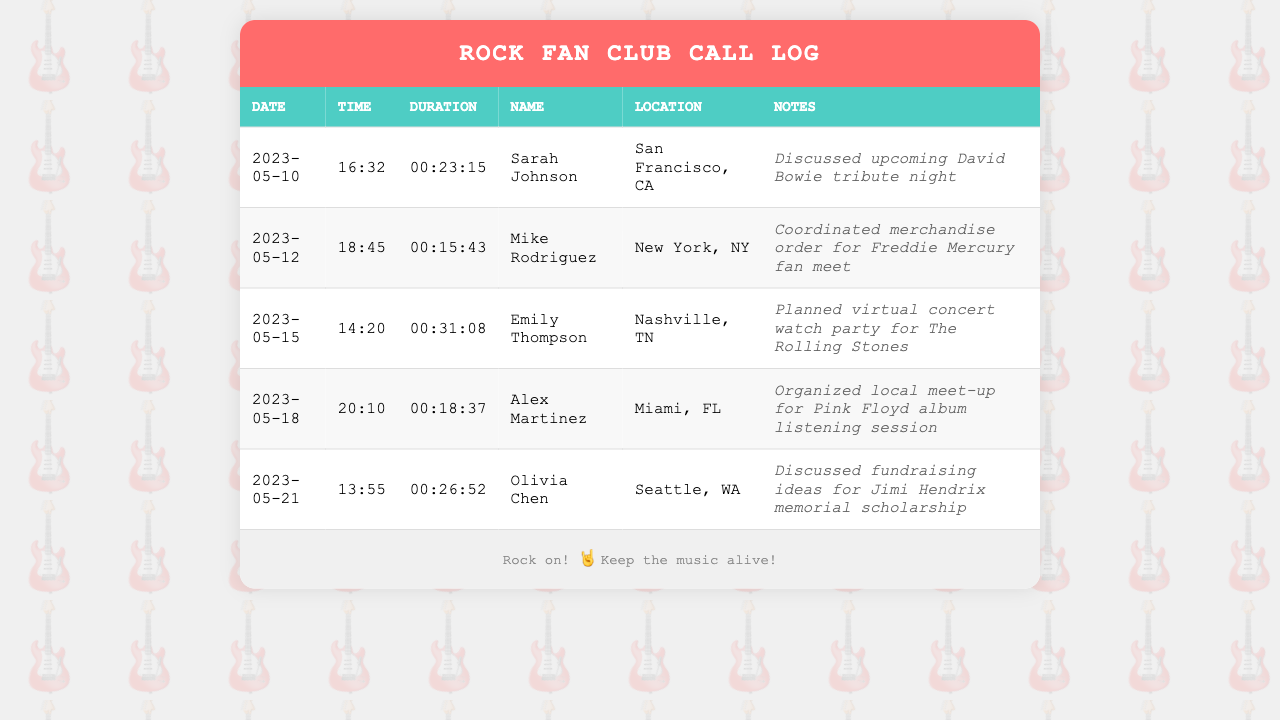What is the date of the longest call? The longest call is with Emily Thompson on May 15, 2023, lasting 00:31:08.
Answer: 2023-05-15 Who called from Miami, FL? The entry related to Miami, FL is a call to Alex Martinez.
Answer: Alex Martinez What was discussed during the call with Sarah Johnson? The notes state that Sarah Johnson discussed an upcoming David Bowie tribute night.
Answer: Upcoming David Bowie tribute night How many calls were made in May 2023? There are five call entries in May 2023.
Answer: 5 Which fan club member is located in Seattle, WA? The document lists Olivia Chen as the member in Seattle, WA.
Answer: Olivia Chen What time was the call with Mike Rodriguez? The call with Mike Rodriguez took place at 18:45 on May 12, 2023.
Answer: 18:45 What was the duration of the call with Alex Martinez? The document shows that the call with Alex Martinez lasted 00:18:37.
Answer: 00:18:37 What type of event was planned with Emily Thompson? According to the notes, a virtual concert watch party for The Rolling Stones was planned.
Answer: Virtual concert watch party What was the purpose of the call with Olivia Chen? The call with Olivia Chen was focused on fundraising ideas for a Jimi Hendrix memorial scholarship.
Answer: Fundraising ideas for Jimi Hendrix memorial scholarship 